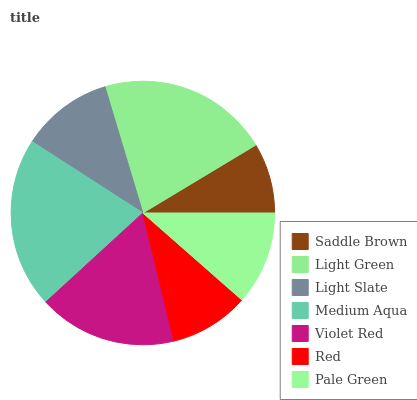Is Saddle Brown the minimum?
Answer yes or no. Yes. Is Light Green the maximum?
Answer yes or no. Yes. Is Light Slate the minimum?
Answer yes or no. No. Is Light Slate the maximum?
Answer yes or no. No. Is Light Green greater than Light Slate?
Answer yes or no. Yes. Is Light Slate less than Light Green?
Answer yes or no. Yes. Is Light Slate greater than Light Green?
Answer yes or no. No. Is Light Green less than Light Slate?
Answer yes or no. No. Is Pale Green the high median?
Answer yes or no. Yes. Is Pale Green the low median?
Answer yes or no. Yes. Is Light Slate the high median?
Answer yes or no. No. Is Light Slate the low median?
Answer yes or no. No. 